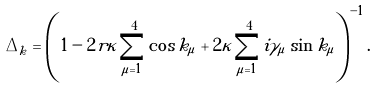Convert formula to latex. <formula><loc_0><loc_0><loc_500><loc_500>\tilde { \Delta } _ { k } = \left ( 1 - 2 r \kappa \sum _ { \mu = 1 } ^ { 4 } \cos k _ { \mu } + 2 \kappa \sum _ { \mu = 1 } ^ { 4 } i \gamma _ { \mu } \sin k _ { \mu } \right ) ^ { - 1 } .</formula> 